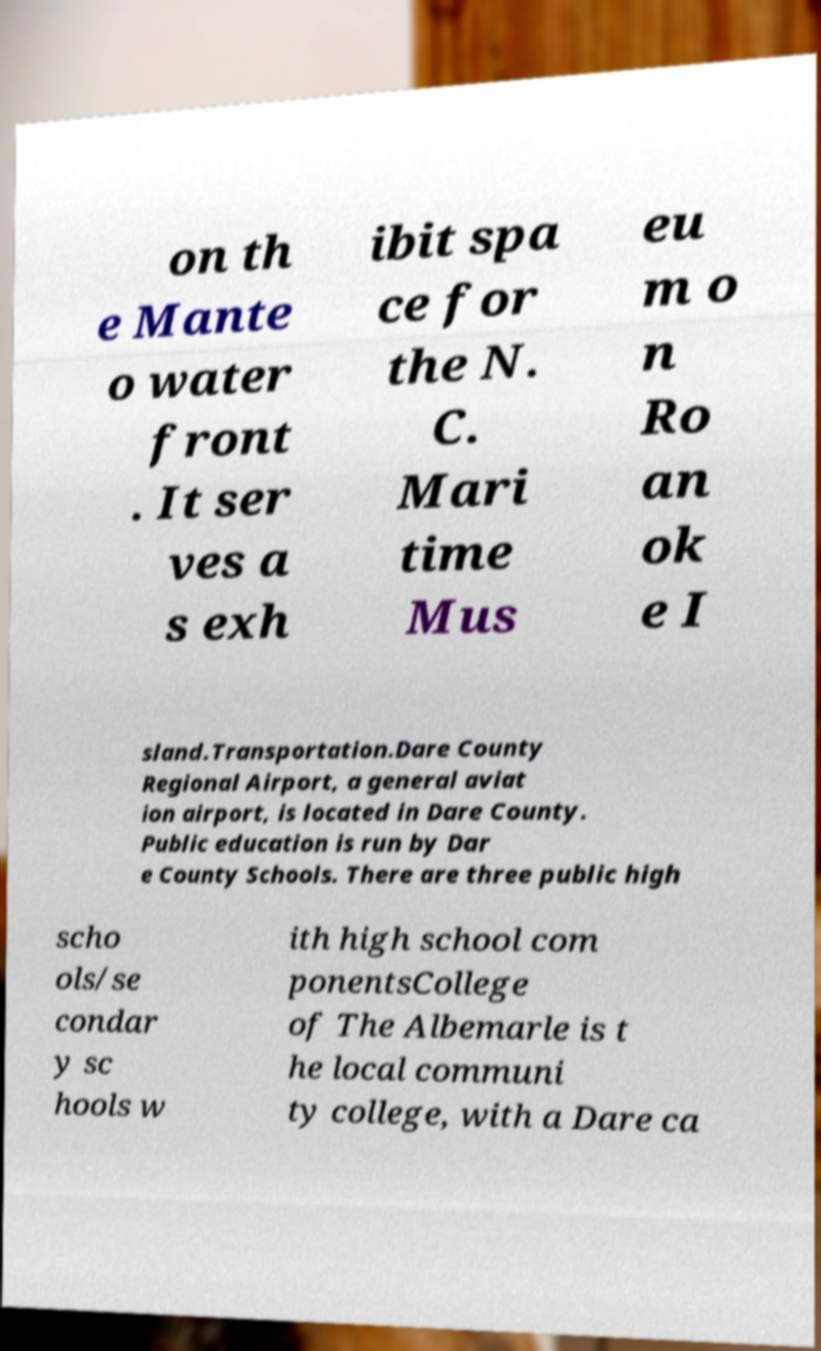Please identify and transcribe the text found in this image. on th e Mante o water front . It ser ves a s exh ibit spa ce for the N. C. Mari time Mus eu m o n Ro an ok e I sland.Transportation.Dare County Regional Airport, a general aviat ion airport, is located in Dare County. Public education is run by Dar e County Schools. There are three public high scho ols/se condar y sc hools w ith high school com ponentsCollege of The Albemarle is t he local communi ty college, with a Dare ca 